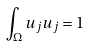<formula> <loc_0><loc_0><loc_500><loc_500>\int _ { \Omega } u _ { j } u _ { j } = 1</formula> 